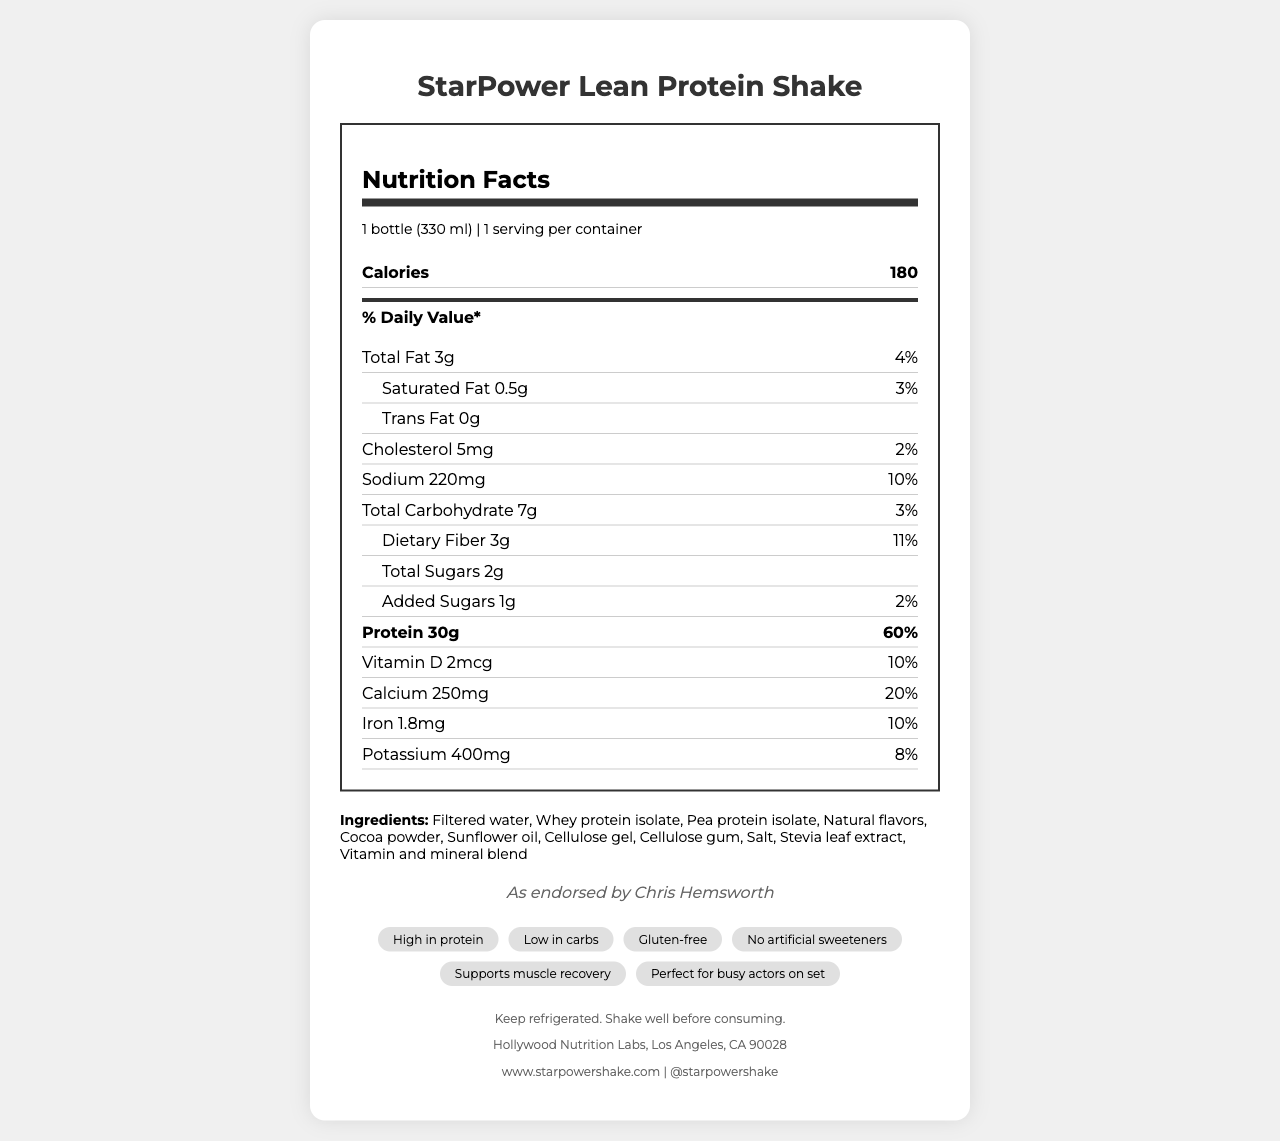what is the serving size of the StarPower Lean Protein Shake? The serving size information is located at the top of the Nutrition Facts section, where it states "1 bottle (330 ml)".
Answer: 1 bottle (330 ml) how many grams of protein does each serving contain? The amount of protein per serving is listed in the Protein section of the Nutrition Facts, showing "30g".
Answer: 30g what percentage of the daily value for protein does the shake provide? The daily value percentage for protein is displayed next to the protein amount, indicating "60%".
Answer: 60% what is the amount of dietary fiber per serving? The amount of dietary fiber per serving is stated under the Total Carbohydrate section as "3g".
Answer: 3g how much calcium does one bottle of the shake provide? The Vitamin and Mineral content section lists calcium as providing "250mg".
Answer: 250mg what is the daily value percentage for iron provided by the shake? A. 5% B. 10% C. 15% D. 20% The daily value percentage for iron is indicated in the document as "10%".
Answer: B how much cholesterol is in one serving of the shake? The Nutrient Facts section lists the cholesterol content per serving as "5mg".
Answer: 5mg which prominent actor endorses the StarPower Lean Protein Shake? A. Chris Evans B. Chris Hemsworth C. Dwayne Johnson D. Gal Gadot The endorsement is stated at the bottom of the document, attributing the promotion to Chris Hemsworth.
Answer: B is the StarPower Lean Protein Shake gluten-free? The document lists the product claims, which include "Gluten-free".
Answer: Yes summarize the main features and nutritional benefits of the StarPower Lean Protein Shake. This summary includes the product claims, nutritional highlights, endorsement, and other benefits listed in the document.
Answer: The StarPower Lean Protein Shake is a high-protein, low-carb meal replacement endorsed by Chris Hemsworth. It contains 30g of protein, 3g of dietary fiber, and low amounts of fat and carbs. It is gluten-free, contains no artificial sweeteners, and offers various vitamins and minerals to support muscle recovery. can this shake be considered a good source of Vitamin C? The shake contains 18mg of Vitamin C, which is 20% of the daily value, indicating it as a good source of Vitamin C.
Answer: Yes how many grams of total sugars does the shake contain? The total sugars content is listed under the Total Carbohydrate section as "2g".
Answer: 2g are there any artificial sweeteners in the shake? One of the product claims explicitly states "No artificial sweeteners".
Answer: No what are the main protein sources in the shake? The ingredients list mentions both "Whey protein isolate" and "Pea protein isolate" as the primary protein sources.
Answer: Whey protein isolate, Pea protein isolate what is the total amount of sodium per serving? The sodium content per serving is listed as "220mg" in the Nutrient Facts section.
Answer: 220mg who manufactures the StarPower Lean Protein Shake? The manufacturer's information is located at the bottom of the document in the footer section.
Answer: Hollywood Nutrition Labs, Los Angeles, CA 90028 does the shake contain any allergenic ingredients? The document lists "Contains milk" under allergens, indicating its presence.
Answer: Yes what flavors are used in the shake? The ingredients list includes "Natural flavors" and "Cocoa powder" for flavoring.
Answer: Natural flavors, Cocoa powder what are the storage instructions for the shake? The storage instructions can be found towards the end of the document, advising to keep refrigerated and to shake well before consuming.
Answer: Keep refrigerated. Shake well before consuming. where can additional information about the StarPower Lean Protein Shake be found? The website and social media handle for more information are provided in the footer section of the document.
Answer: www.starpowershake.com, @starpowershake did Chris Hemsworth help to create the StarPower Lean Protein Shake? The document does not provide any information about Chris Hemsworth's involvement in the creation of the shake, only that it is endorsed by him.
Answer: Not enough information 